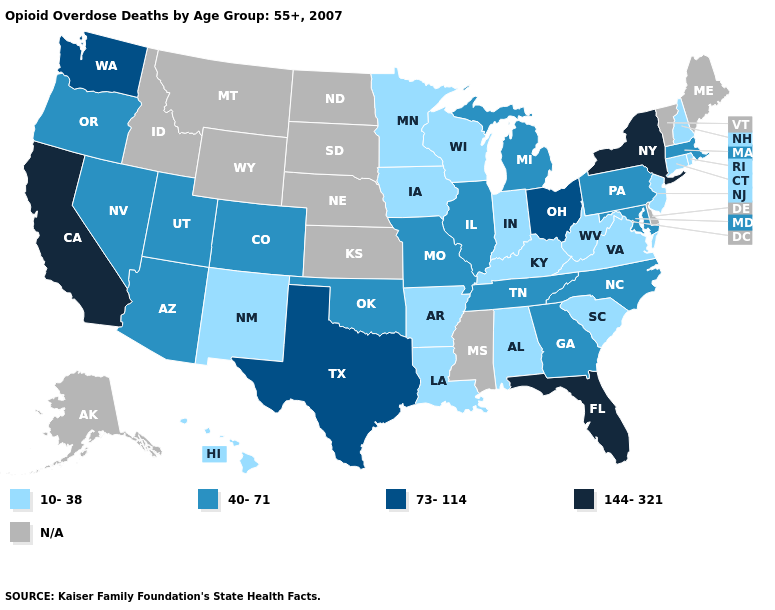Does the first symbol in the legend represent the smallest category?
Keep it brief. Yes. What is the value of Maryland?
Keep it brief. 40-71. Does the map have missing data?
Quick response, please. Yes. What is the value of New Mexico?
Answer briefly. 10-38. Name the states that have a value in the range N/A?
Quick response, please. Alaska, Delaware, Idaho, Kansas, Maine, Mississippi, Montana, Nebraska, North Dakota, South Dakota, Vermont, Wyoming. Name the states that have a value in the range 10-38?
Keep it brief. Alabama, Arkansas, Connecticut, Hawaii, Indiana, Iowa, Kentucky, Louisiana, Minnesota, New Hampshire, New Jersey, New Mexico, Rhode Island, South Carolina, Virginia, West Virginia, Wisconsin. Which states hav the highest value in the West?
Quick response, please. California. What is the value of Utah?
Quick response, please. 40-71. Which states hav the highest value in the Northeast?
Concise answer only. New York. Name the states that have a value in the range N/A?
Concise answer only. Alaska, Delaware, Idaho, Kansas, Maine, Mississippi, Montana, Nebraska, North Dakota, South Dakota, Vermont, Wyoming. Which states have the lowest value in the USA?
Write a very short answer. Alabama, Arkansas, Connecticut, Hawaii, Indiana, Iowa, Kentucky, Louisiana, Minnesota, New Hampshire, New Jersey, New Mexico, Rhode Island, South Carolina, Virginia, West Virginia, Wisconsin. Name the states that have a value in the range 144-321?
Short answer required. California, Florida, New York. Which states have the lowest value in the USA?
Write a very short answer. Alabama, Arkansas, Connecticut, Hawaii, Indiana, Iowa, Kentucky, Louisiana, Minnesota, New Hampshire, New Jersey, New Mexico, Rhode Island, South Carolina, Virginia, West Virginia, Wisconsin. 